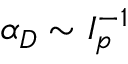Convert formula to latex. <formula><loc_0><loc_0><loc_500><loc_500>\alpha _ { D } \sim I _ { p } ^ { - 1 }</formula> 